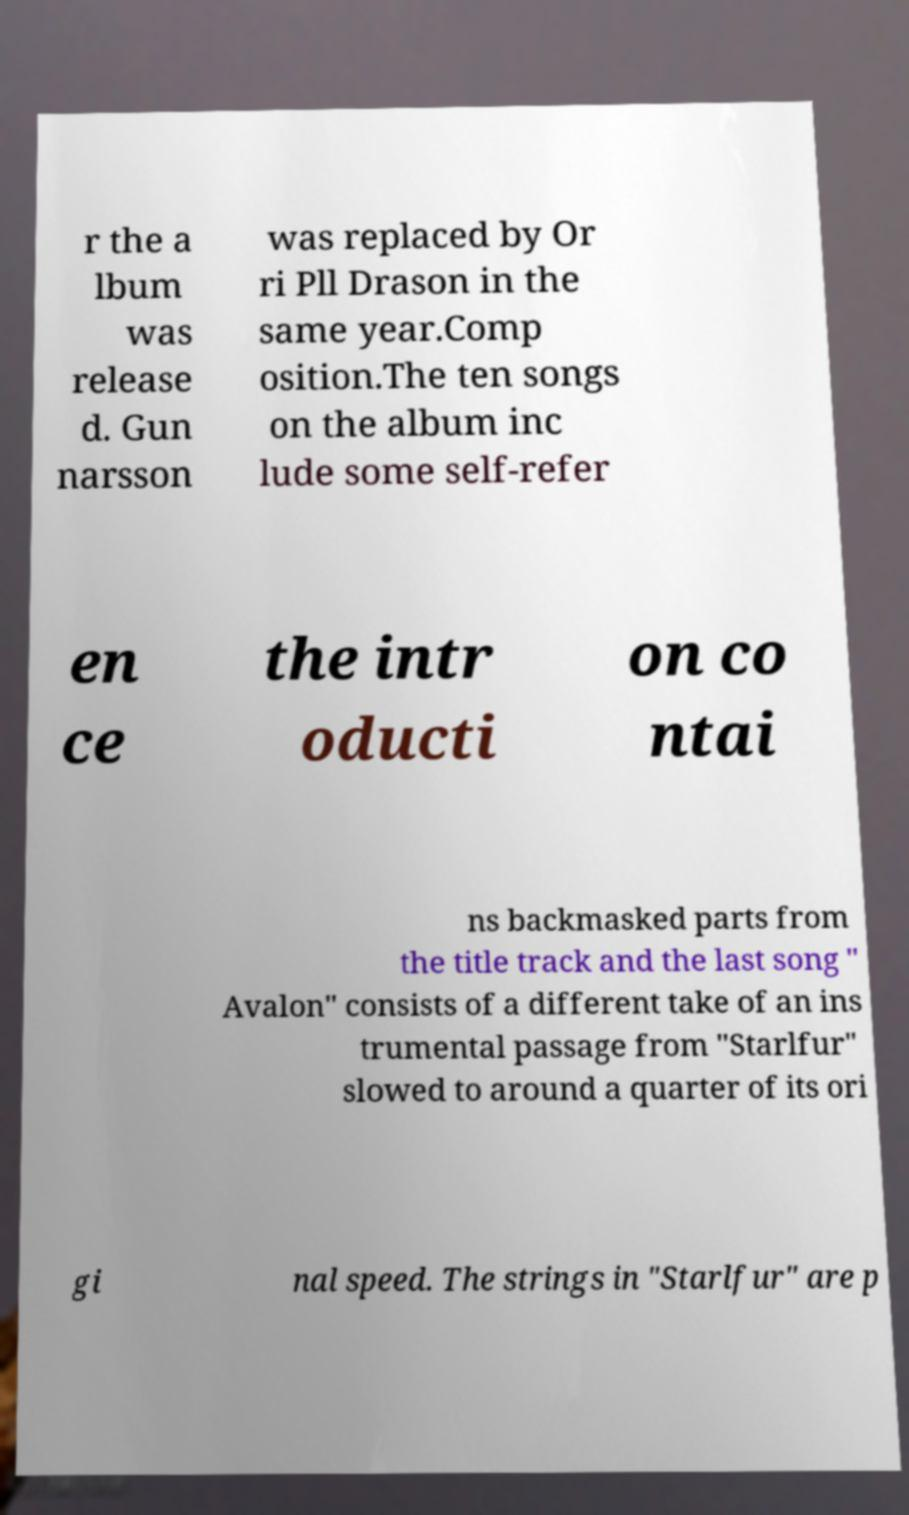I need the written content from this picture converted into text. Can you do that? r the a lbum was release d. Gun narsson was replaced by Or ri Pll Drason in the same year.Comp osition.The ten songs on the album inc lude some self-refer en ce the intr oducti on co ntai ns backmasked parts from the title track and the last song " Avalon" consists of a different take of an ins trumental passage from "Starlfur" slowed to around a quarter of its ori gi nal speed. The strings in "Starlfur" are p 